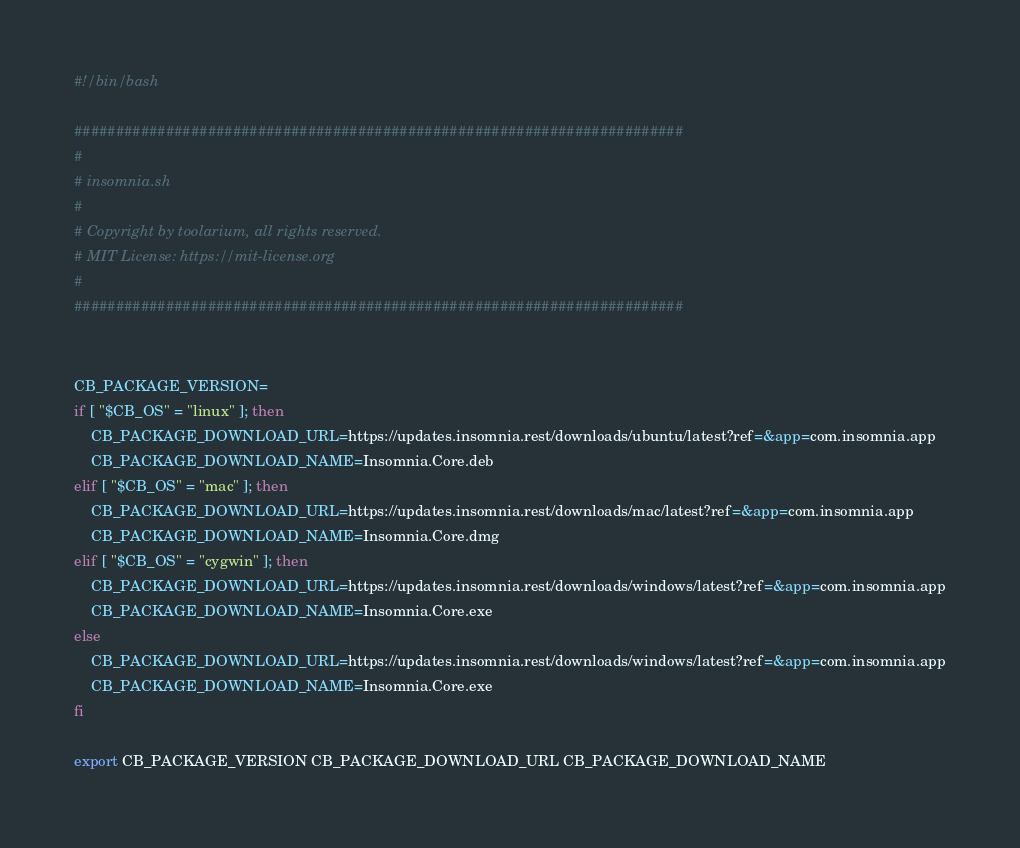<code> <loc_0><loc_0><loc_500><loc_500><_Bash_>#!/bin/bash

#########################################################################
#
# insomnia.sh
#
# Copyright by toolarium, all rights reserved.
# MIT License: https://mit-license.org
#
#########################################################################


CB_PACKAGE_VERSION=
if [ "$CB_OS" = "linux" ]; then
	CB_PACKAGE_DOWNLOAD_URL=https://updates.insomnia.rest/downloads/ubuntu/latest?ref=&app=com.insomnia.app
	CB_PACKAGE_DOWNLOAD_NAME=Insomnia.Core.deb
elif [ "$CB_OS" = "mac" ]; then
	CB_PACKAGE_DOWNLOAD_URL=https://updates.insomnia.rest/downloads/mac/latest?ref=&app=com.insomnia.app
	CB_PACKAGE_DOWNLOAD_NAME=Insomnia.Core.dmg
elif [ "$CB_OS" = "cygwin" ]; then
	CB_PACKAGE_DOWNLOAD_URL=https://updates.insomnia.rest/downloads/windows/latest?ref=&app=com.insomnia.app
	CB_PACKAGE_DOWNLOAD_NAME=Insomnia.Core.exe
else
	CB_PACKAGE_DOWNLOAD_URL=https://updates.insomnia.rest/downloads/windows/latest?ref=&app=com.insomnia.app
	CB_PACKAGE_DOWNLOAD_NAME=Insomnia.Core.exe
fi

export CB_PACKAGE_VERSION CB_PACKAGE_DOWNLOAD_URL CB_PACKAGE_DOWNLOAD_NAME</code> 